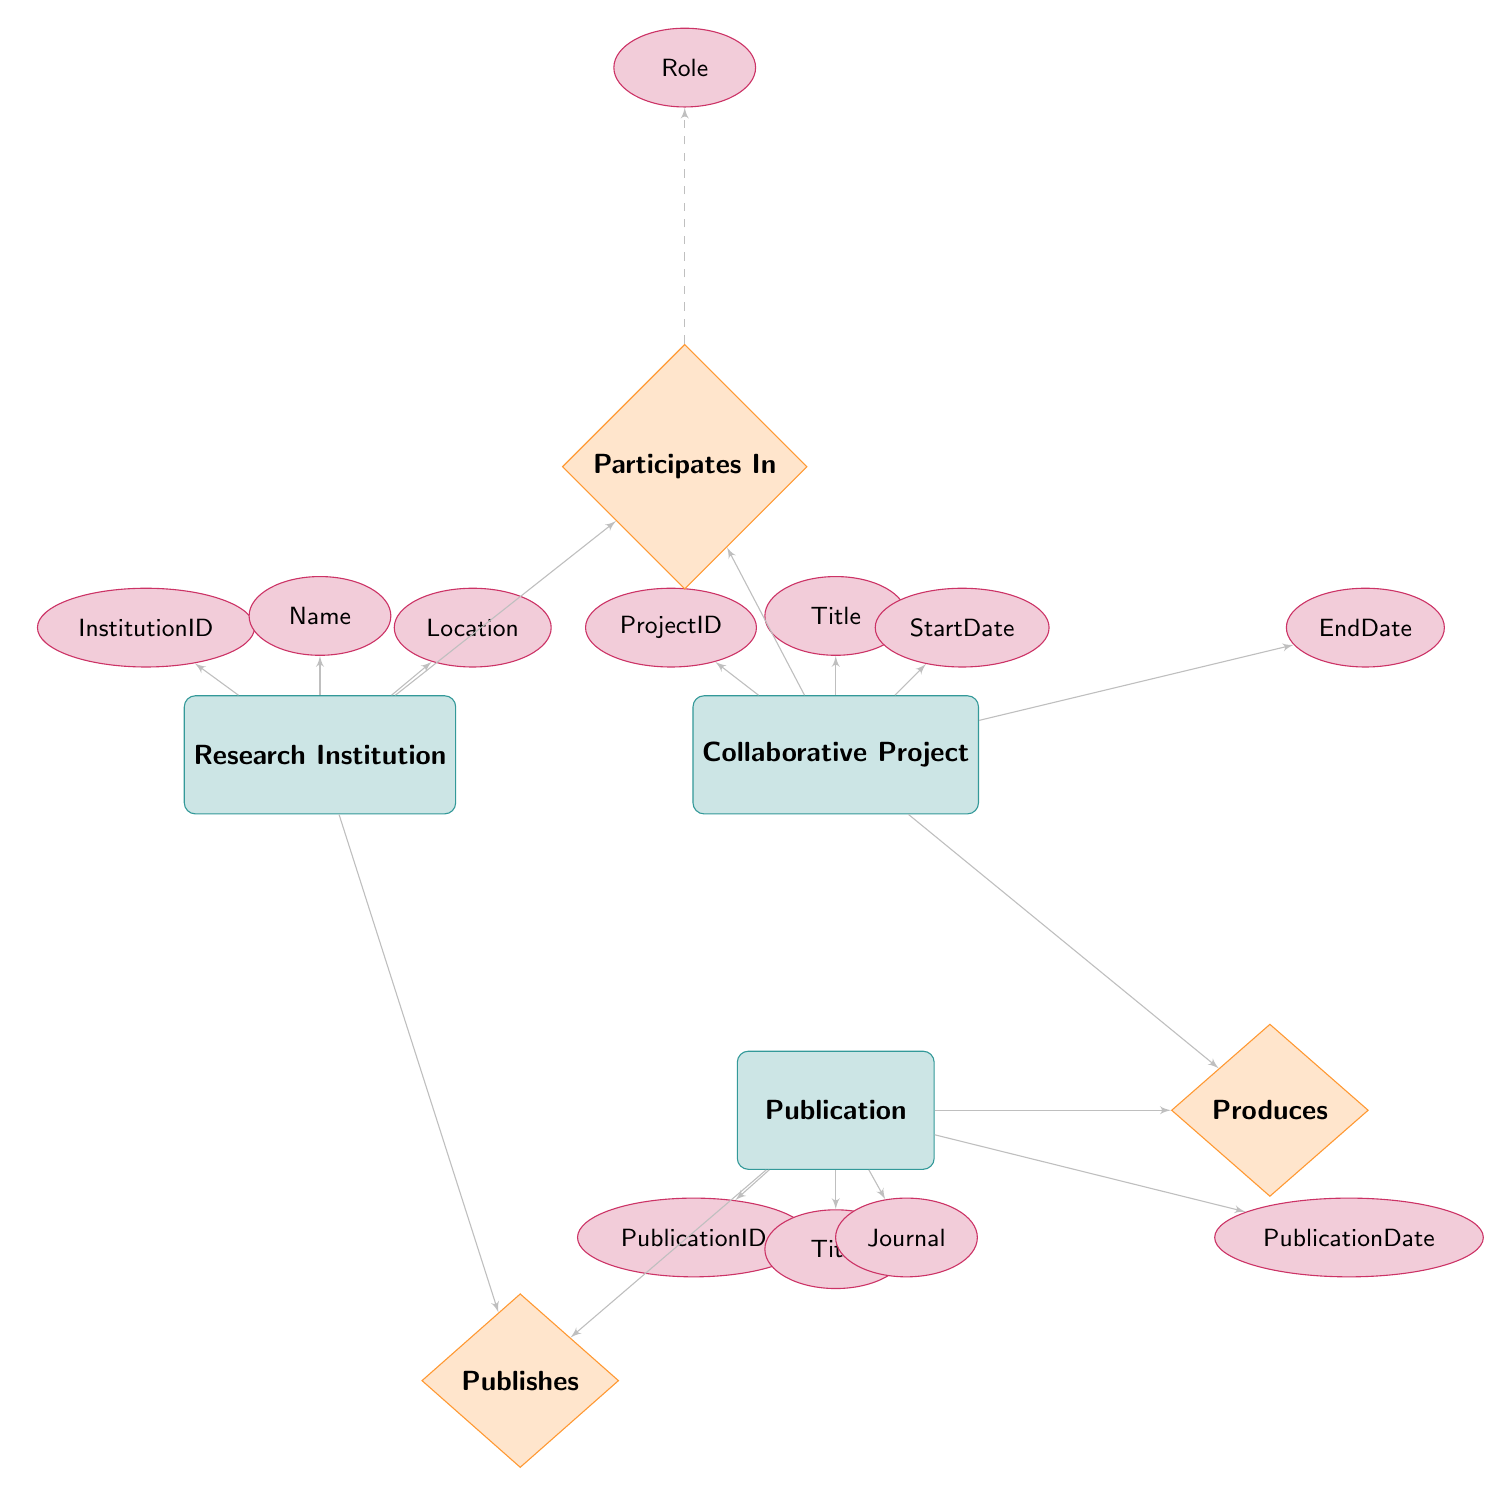What is the primary key of the Research Institution entity? The primary key of the Research Institution entity is specified as "InstitutionID." This information is indicated within the entity block, highlighting the unique identifier for each research institution.
Answer: InstitutionID How many attributes does the Collaborative Project entity have? The Collaborative Project entity has four attributes listed: "ProjectID," "Title," "StartDate," and "EndDate." Counting these gives a total of four attributes.
Answer: 4 What relationship connects Research Institutions to Collaborative Projects? The relationship that connects Research Institutions to Collaborative Projects is labeled "Participates In." This relationship indicates the involvement of institutions in various collaborative projects.
Answer: Participates In What additional attribute is associated with the relationship "Institution Participates In Project"? The additional attribute for the "Institution Participates In Project" relationship is "Role." This is represented in a dashed line from the relationship, indicating how institutions participate in different roles in projects.
Answer: Role Which entity is related to the Publication entity through the "Produces" relationship? The entity related to the Publication entity through the "Produces" relationship is "Collaborative Project." This relationship indicates that publications are outcomes of collaborative projects.
Answer: Collaborative Project How many relationships are there in total in the diagram? There are three relationships depicted in the diagram: "Participates In," "Produces," and "Publishes." This includes all connections between entities and their respective roles.
Answer: 3 How is the Publication entity linked to the Research Institution? The Publication entity is linked to the Research Institution through the relationship "Publishes." This relationship illustrates that institutions are responsible for publishing various research outcomes.
Answer: Publishes What type of diagram is represented here? This diagram represents an Entity Relationship Diagram, which visually displays the entities, their attributes, and the relationships between them in a systematic manner.
Answer: Entity Relationship Diagram 